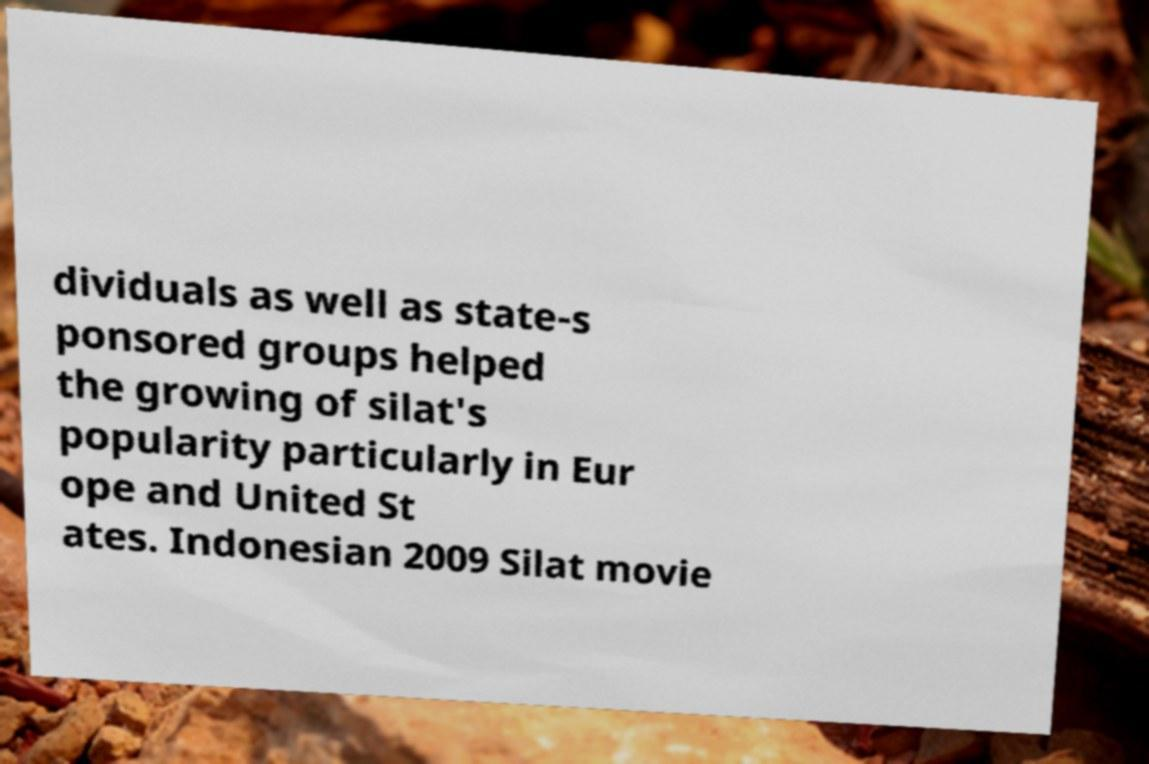I need the written content from this picture converted into text. Can you do that? dividuals as well as state-s ponsored groups helped the growing of silat's popularity particularly in Eur ope and United St ates. Indonesian 2009 Silat movie 